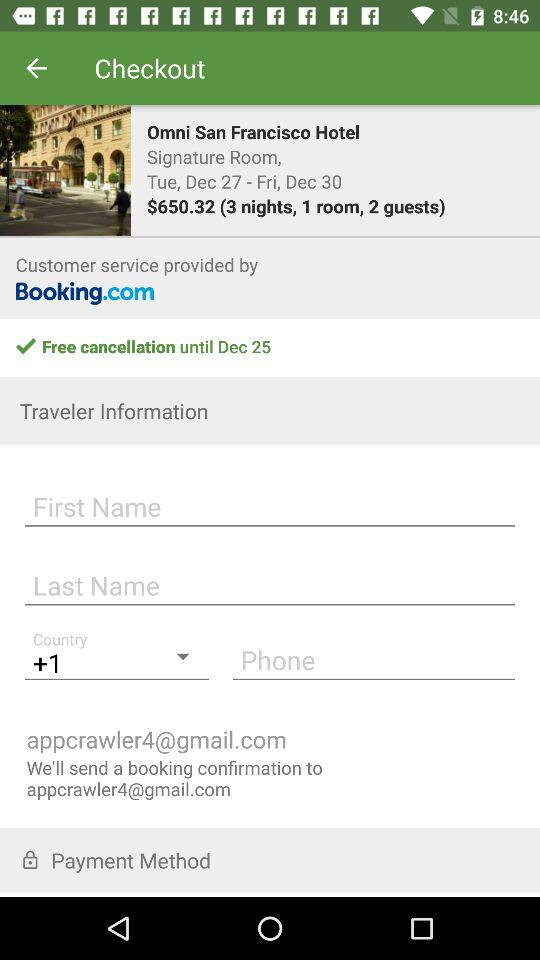How many guests are booked?
Answer the question using a single word or phrase. 2 